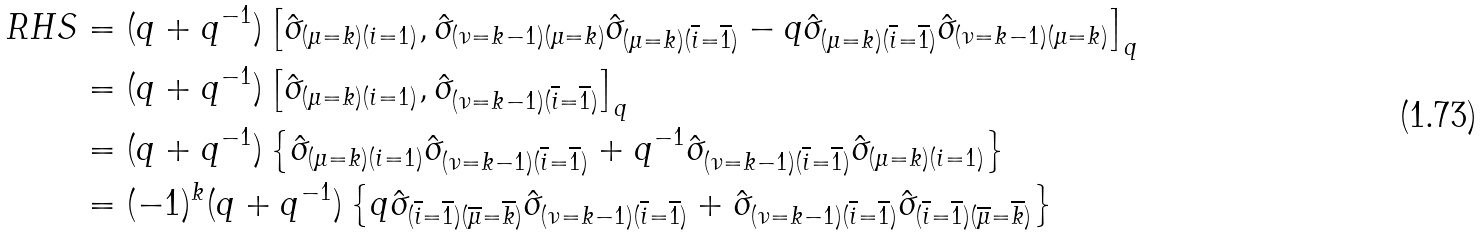<formula> <loc_0><loc_0><loc_500><loc_500>R H S & = ( q + q ^ { - 1 } ) \left [ \hat { \sigma } _ { ( \mu = k ) ( i = 1 ) } , \hat { \sigma } _ { ( \nu = k - 1 ) ( \mu = k ) } \hat { \sigma } _ { ( \mu = k ) ( \overline { i } = \overline { 1 } ) } - q \hat { \sigma } _ { ( \mu = k ) ( \overline { i } = \overline { 1 } ) } \hat { \sigma } _ { ( \nu = k - 1 ) ( \mu = k ) } \right ] _ { q } \\ & = ( q + q ^ { - 1 } ) \left [ \hat { \sigma } _ { ( \mu = k ) ( i = 1 ) } , \hat { \sigma } _ { ( \nu = k - 1 ) ( \overline { i } = \overline { 1 } ) } \right ] _ { q } \\ & = ( q + q ^ { - 1 } ) \left \{ \hat { \sigma } _ { ( \mu = k ) ( i = 1 ) } \hat { \sigma } _ { ( \nu = k - 1 ) ( \overline { i } = \overline { 1 } ) } + q ^ { - 1 } \hat { \sigma } _ { ( \nu = k - 1 ) ( \overline { i } = \overline { 1 } ) } \hat { \sigma } _ { ( \mu = k ) ( i = 1 ) } \right \} \\ & = ( - 1 ) ^ { k } ( q + q ^ { - 1 } ) \left \{ q \hat { \sigma } _ { ( \overline { i } = \overline { 1 } ) ( \overline { \mu } = \overline { k } ) } \hat { \sigma } _ { ( \nu = k - 1 ) ( \overline { i } = \overline { 1 } ) } + \hat { \sigma } _ { ( \nu = k - 1 ) ( \overline { i } = \overline { 1 } ) } \hat { \sigma } _ { ( \overline { i } = \overline { 1 } ) ( \overline { \mu } = \overline { k } ) } \right \}</formula> 